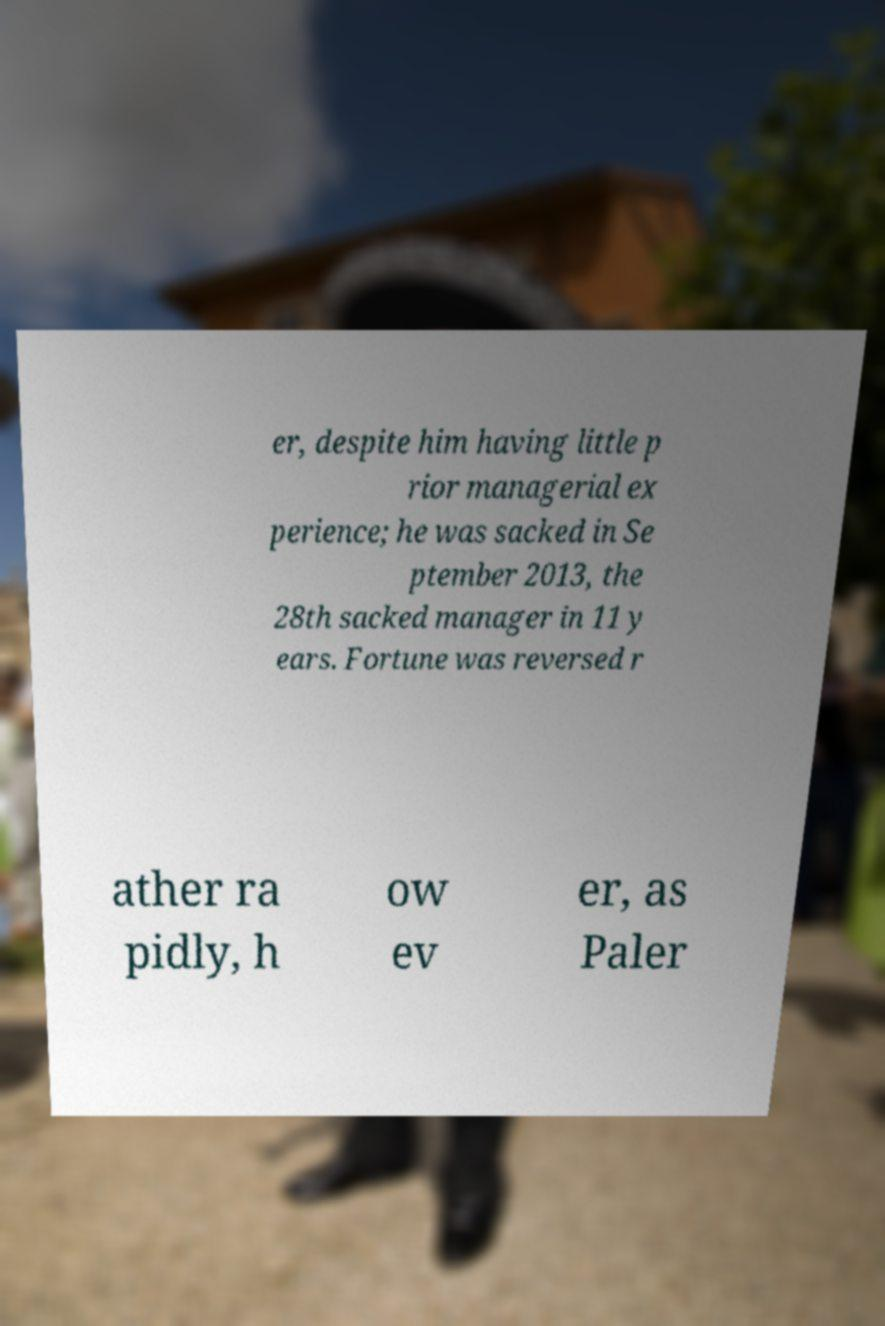Can you accurately transcribe the text from the provided image for me? er, despite him having little p rior managerial ex perience; he was sacked in Se ptember 2013, the 28th sacked manager in 11 y ears. Fortune was reversed r ather ra pidly, h ow ev er, as Paler 